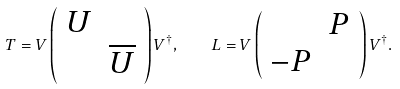<formula> <loc_0><loc_0><loc_500><loc_500>T = V \left ( \begin{array} { l l } U & \\ & \overline { U } \end{array} \right ) V ^ { \dagger } , \quad L = V \left ( \begin{array} { l l } & P \\ - P & \end{array} \right ) V ^ { \dagger } .</formula> 